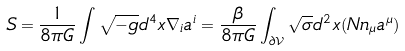Convert formula to latex. <formula><loc_0><loc_0><loc_500><loc_500>S = \frac { 1 } { 8 \pi G } \int \sqrt { - g } d ^ { 4 } x \nabla _ { i } a ^ { i } = \frac { \beta } { 8 \pi G } \int _ { \partial \mathcal { V } } \sqrt { \sigma } d ^ { 2 } x ( N n _ { \mu } a ^ { \mu } )</formula> 